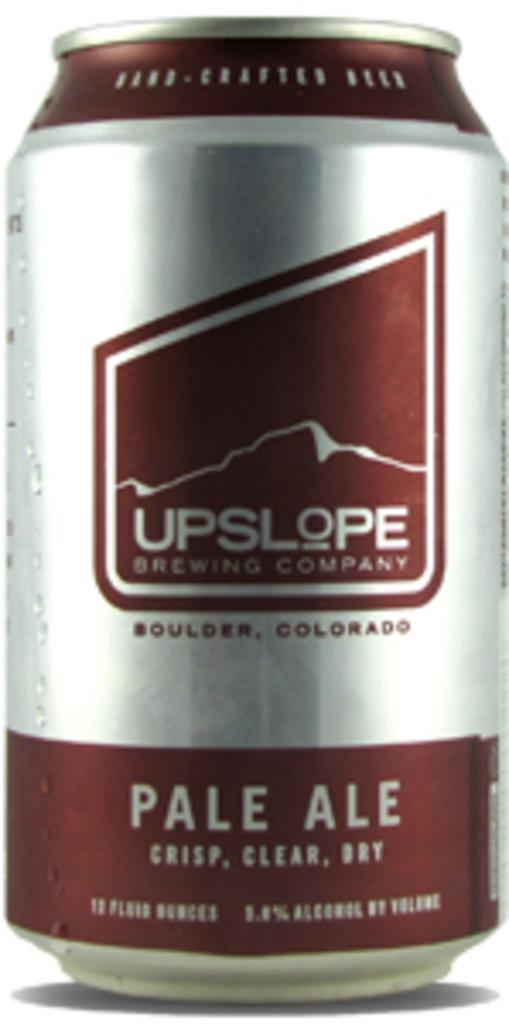What color combination can be seen on the can in the image? The can in the image has a brown and silver color combination. What color is the background of the image? The background of the image is white. How many fish are swimming in the news on the image? There are no fish or news present in the image; it features a brown and silver can against a white background. 